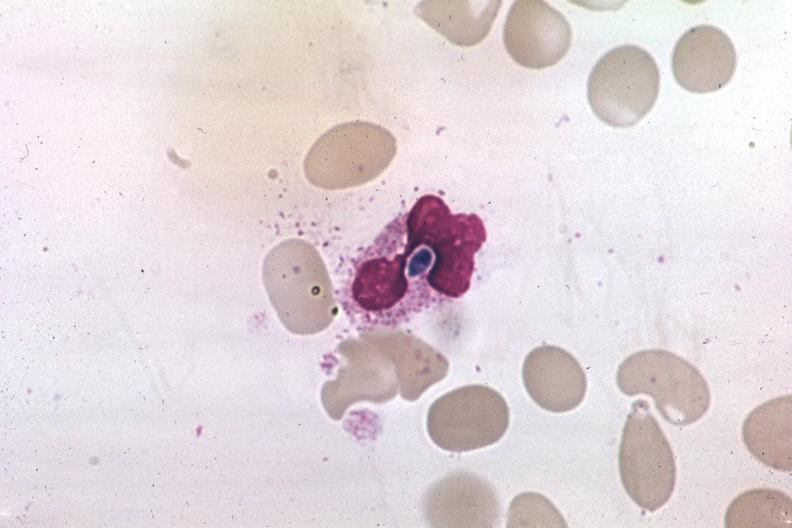does this image show wrights yeast form in a neutrophil?
Answer the question using a single word or phrase. Yes 